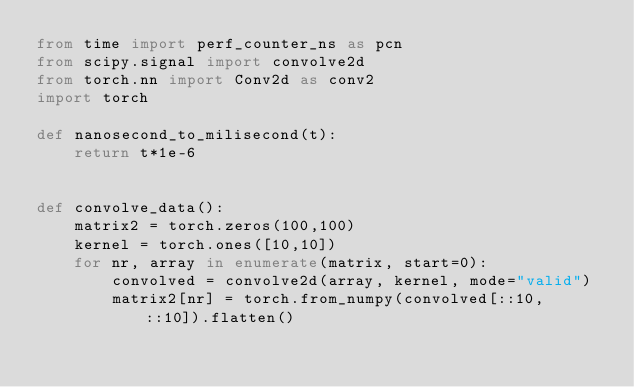<code> <loc_0><loc_0><loc_500><loc_500><_Python_>from time import perf_counter_ns as pcn
from scipy.signal import convolve2d
from torch.nn import Conv2d as conv2
import torch

def nanosecond_to_milisecond(t):
    return t*1e-6


def convolve_data():
    matrix2 = torch.zeros(100,100)
    kernel = torch.ones([10,10])
    for nr, array in enumerate(matrix, start=0):
        convolved = convolve2d(array, kernel, mode="valid")
        matrix2[nr] = torch.from_numpy(convolved[::10, ::10]).flatten()</code> 